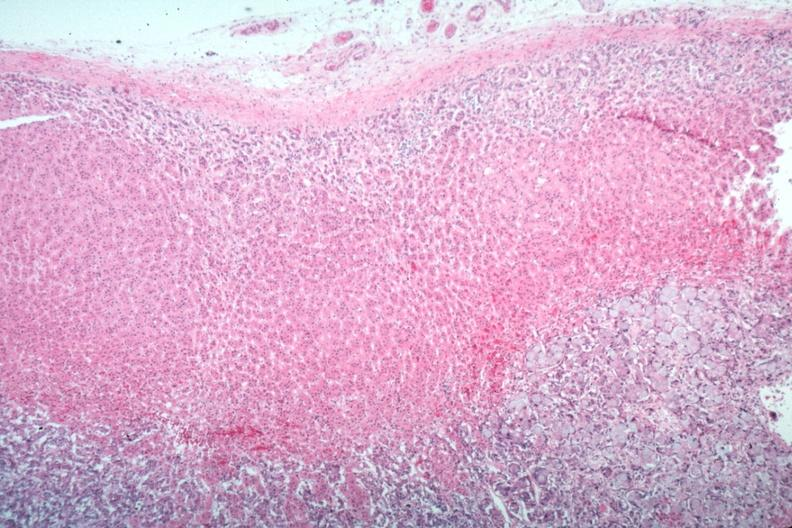does this image show primary in stomach?
Answer the question using a single word or phrase. Yes 